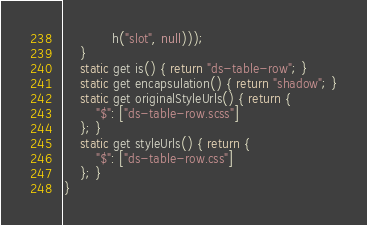Convert code to text. <code><loc_0><loc_0><loc_500><loc_500><_JavaScript_>            h("slot", null)));
    }
    static get is() { return "ds-table-row"; }
    static get encapsulation() { return "shadow"; }
    static get originalStyleUrls() { return {
        "$": ["ds-table-row.scss"]
    }; }
    static get styleUrls() { return {
        "$": ["ds-table-row.css"]
    }; }
}
</code> 